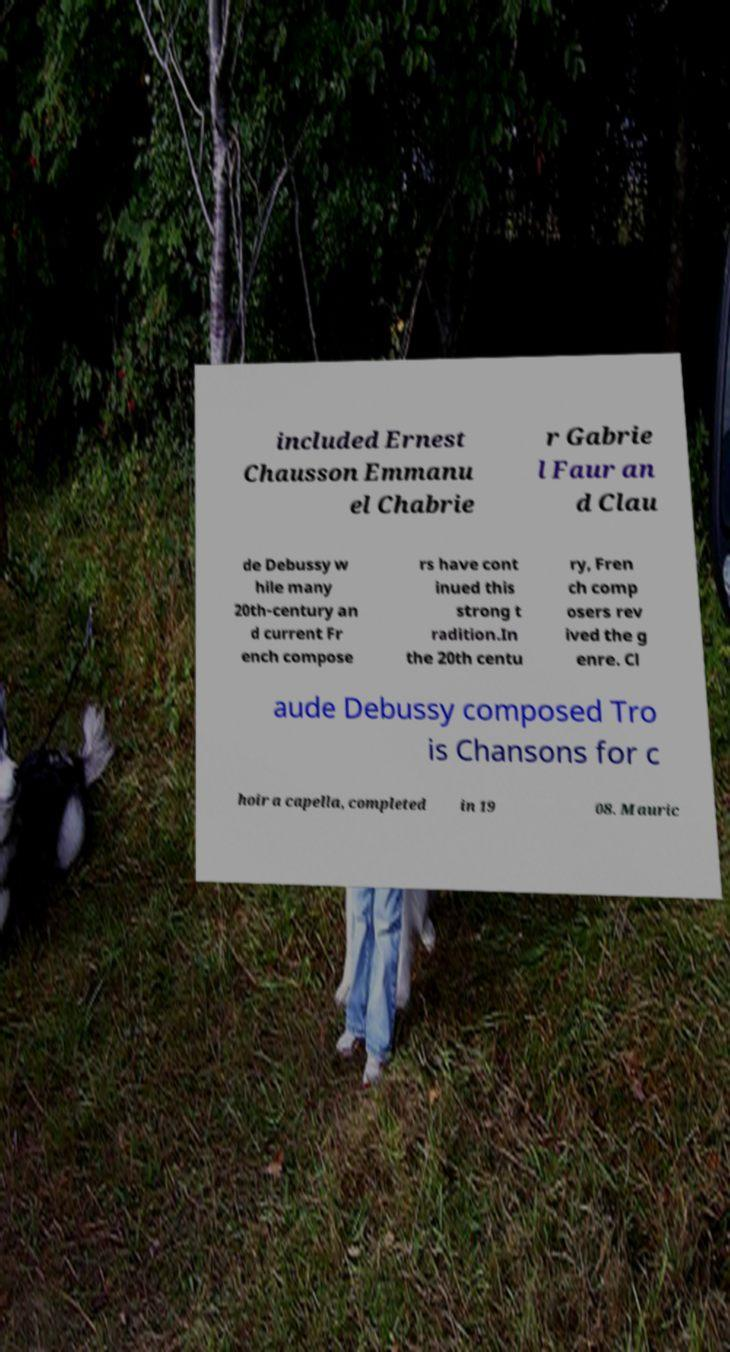Could you assist in decoding the text presented in this image and type it out clearly? included Ernest Chausson Emmanu el Chabrie r Gabrie l Faur an d Clau de Debussy w hile many 20th-century an d current Fr ench compose rs have cont inued this strong t radition.In the 20th centu ry, Fren ch comp osers rev ived the g enre. Cl aude Debussy composed Tro is Chansons for c hoir a capella, completed in 19 08. Mauric 